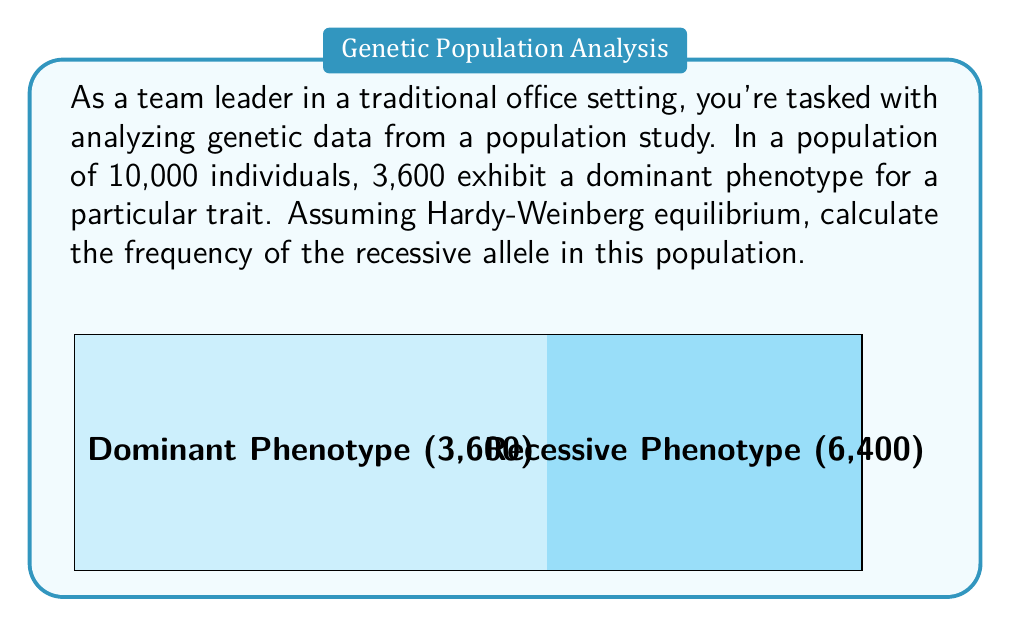Could you help me with this problem? Let's solve this step-by-step using the Hardy-Weinberg principle:

1) Let $p$ be the frequency of the dominant allele and $q$ be the frequency of the recessive allele.

2) The Hardy-Weinberg principle states that $p + q = 1$

3) In a population in Hardy-Weinberg equilibrium:
   $p^2$ = frequency of homozygous dominant individuals
   $2pq$ = frequency of heterozygous individuals
   $q^2$ = frequency of homozygous recessive individuals

4) The dominant phenotype includes both homozygous dominant and heterozygous individuals:
   $p^2 + 2pq = 3600/10000 = 0.36$

5) We can express this in terms of $q$:
   $(1-q)^2 + 2q(1-q) = 0.36$

6) Expanding this equation:
   $1 - 2q + q^2 + 2q - 2q^2 = 0.36$
   $1 - q^2 = 0.36$

7) Solving for $q^2$:
   $q^2 = 1 - 0.36 = 0.64$

8) Taking the square root:
   $q = \sqrt{0.64} = 0.8$

Therefore, the frequency of the recessive allele is 0.8 or 80%.
Answer: $q = 0.8$ 